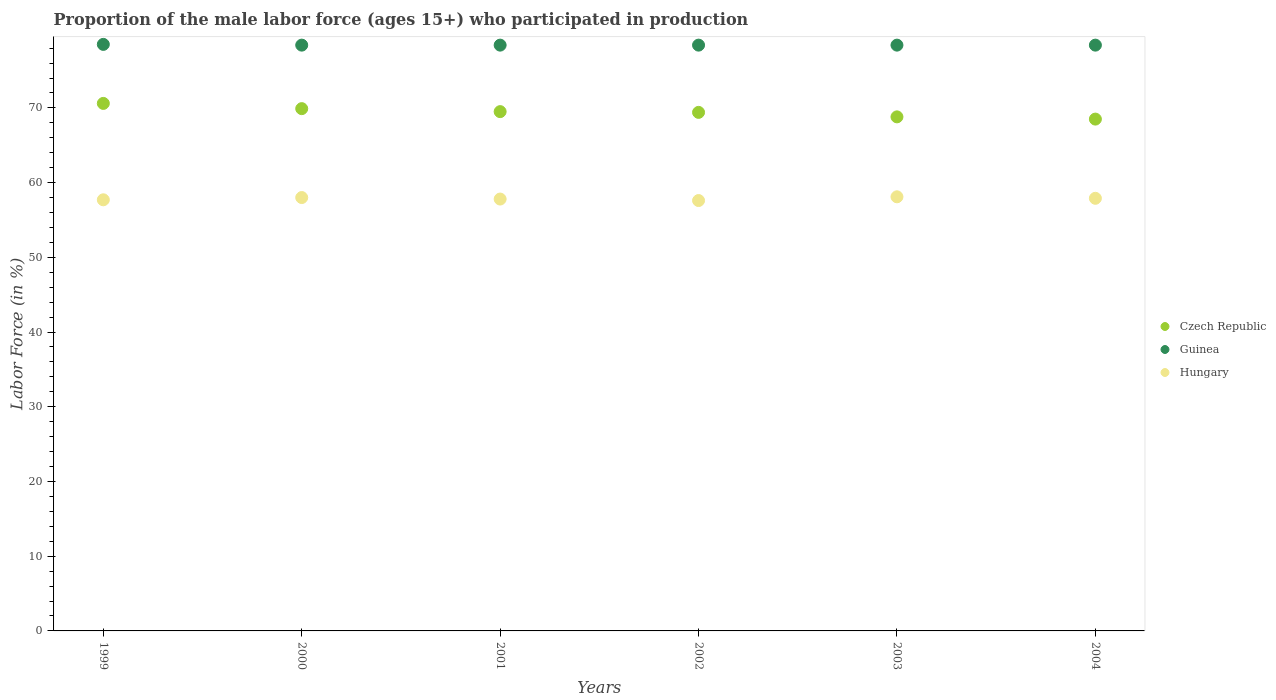How many different coloured dotlines are there?
Offer a terse response. 3. Is the number of dotlines equal to the number of legend labels?
Keep it short and to the point. Yes. What is the proportion of the male labor force who participated in production in Guinea in 2003?
Keep it short and to the point. 78.4. Across all years, what is the maximum proportion of the male labor force who participated in production in Czech Republic?
Provide a short and direct response. 70.6. Across all years, what is the minimum proportion of the male labor force who participated in production in Czech Republic?
Make the answer very short. 68.5. What is the total proportion of the male labor force who participated in production in Guinea in the graph?
Offer a terse response. 470.5. What is the difference between the proportion of the male labor force who participated in production in Guinea in 2002 and that in 2003?
Your answer should be compact. 0. What is the average proportion of the male labor force who participated in production in Czech Republic per year?
Offer a terse response. 69.45. In the year 1999, what is the difference between the proportion of the male labor force who participated in production in Hungary and proportion of the male labor force who participated in production in Guinea?
Your response must be concise. -20.8. In how many years, is the proportion of the male labor force who participated in production in Hungary greater than 60 %?
Provide a succinct answer. 0. What is the ratio of the proportion of the male labor force who participated in production in Hungary in 1999 to that in 2001?
Keep it short and to the point. 1. What is the difference between the highest and the second highest proportion of the male labor force who participated in production in Czech Republic?
Ensure brevity in your answer.  0.7. What is the difference between the highest and the lowest proportion of the male labor force who participated in production in Czech Republic?
Provide a succinct answer. 2.1. How many dotlines are there?
Your response must be concise. 3. What is the difference between two consecutive major ticks on the Y-axis?
Your response must be concise. 10. Are the values on the major ticks of Y-axis written in scientific E-notation?
Provide a short and direct response. No. Does the graph contain any zero values?
Offer a very short reply. No. Where does the legend appear in the graph?
Offer a very short reply. Center right. How many legend labels are there?
Make the answer very short. 3. How are the legend labels stacked?
Make the answer very short. Vertical. What is the title of the graph?
Your answer should be compact. Proportion of the male labor force (ages 15+) who participated in production. What is the label or title of the X-axis?
Offer a very short reply. Years. What is the Labor Force (in %) of Czech Republic in 1999?
Give a very brief answer. 70.6. What is the Labor Force (in %) of Guinea in 1999?
Give a very brief answer. 78.5. What is the Labor Force (in %) of Hungary in 1999?
Your answer should be very brief. 57.7. What is the Labor Force (in %) of Czech Republic in 2000?
Provide a short and direct response. 69.9. What is the Labor Force (in %) of Guinea in 2000?
Provide a succinct answer. 78.4. What is the Labor Force (in %) in Hungary in 2000?
Ensure brevity in your answer.  58. What is the Labor Force (in %) of Czech Republic in 2001?
Offer a very short reply. 69.5. What is the Labor Force (in %) of Guinea in 2001?
Offer a terse response. 78.4. What is the Labor Force (in %) in Hungary in 2001?
Make the answer very short. 57.8. What is the Labor Force (in %) of Czech Republic in 2002?
Your answer should be compact. 69.4. What is the Labor Force (in %) in Guinea in 2002?
Make the answer very short. 78.4. What is the Labor Force (in %) in Hungary in 2002?
Offer a terse response. 57.6. What is the Labor Force (in %) of Czech Republic in 2003?
Your answer should be very brief. 68.8. What is the Labor Force (in %) in Guinea in 2003?
Provide a succinct answer. 78.4. What is the Labor Force (in %) in Hungary in 2003?
Your answer should be compact. 58.1. What is the Labor Force (in %) of Czech Republic in 2004?
Your answer should be compact. 68.5. What is the Labor Force (in %) of Guinea in 2004?
Ensure brevity in your answer.  78.4. What is the Labor Force (in %) of Hungary in 2004?
Offer a very short reply. 57.9. Across all years, what is the maximum Labor Force (in %) in Czech Republic?
Ensure brevity in your answer.  70.6. Across all years, what is the maximum Labor Force (in %) in Guinea?
Your response must be concise. 78.5. Across all years, what is the maximum Labor Force (in %) in Hungary?
Provide a short and direct response. 58.1. Across all years, what is the minimum Labor Force (in %) in Czech Republic?
Your answer should be very brief. 68.5. Across all years, what is the minimum Labor Force (in %) of Guinea?
Give a very brief answer. 78.4. Across all years, what is the minimum Labor Force (in %) in Hungary?
Keep it short and to the point. 57.6. What is the total Labor Force (in %) in Czech Republic in the graph?
Your answer should be very brief. 416.7. What is the total Labor Force (in %) of Guinea in the graph?
Your answer should be compact. 470.5. What is the total Labor Force (in %) of Hungary in the graph?
Keep it short and to the point. 347.1. What is the difference between the Labor Force (in %) in Guinea in 1999 and that in 2000?
Provide a succinct answer. 0.1. What is the difference between the Labor Force (in %) in Czech Republic in 1999 and that in 2002?
Provide a short and direct response. 1.2. What is the difference between the Labor Force (in %) in Guinea in 1999 and that in 2002?
Your answer should be very brief. 0.1. What is the difference between the Labor Force (in %) in Hungary in 1999 and that in 2003?
Give a very brief answer. -0.4. What is the difference between the Labor Force (in %) in Guinea in 1999 and that in 2004?
Offer a terse response. 0.1. What is the difference between the Labor Force (in %) in Hungary in 2000 and that in 2001?
Offer a terse response. 0.2. What is the difference between the Labor Force (in %) of Czech Republic in 2000 and that in 2002?
Give a very brief answer. 0.5. What is the difference between the Labor Force (in %) of Hungary in 2000 and that in 2002?
Provide a succinct answer. 0.4. What is the difference between the Labor Force (in %) in Czech Republic in 2000 and that in 2003?
Provide a succinct answer. 1.1. What is the difference between the Labor Force (in %) in Guinea in 2000 and that in 2003?
Ensure brevity in your answer.  0. What is the difference between the Labor Force (in %) in Hungary in 2000 and that in 2003?
Make the answer very short. -0.1. What is the difference between the Labor Force (in %) in Czech Republic in 2000 and that in 2004?
Ensure brevity in your answer.  1.4. What is the difference between the Labor Force (in %) in Czech Republic in 2001 and that in 2002?
Your response must be concise. 0.1. What is the difference between the Labor Force (in %) of Czech Republic in 2001 and that in 2004?
Provide a short and direct response. 1. What is the difference between the Labor Force (in %) in Hungary in 2002 and that in 2003?
Provide a short and direct response. -0.5. What is the difference between the Labor Force (in %) in Hungary in 2002 and that in 2004?
Make the answer very short. -0.3. What is the difference between the Labor Force (in %) of Hungary in 2003 and that in 2004?
Ensure brevity in your answer.  0.2. What is the difference between the Labor Force (in %) in Czech Republic in 1999 and the Labor Force (in %) in Guinea in 2000?
Ensure brevity in your answer.  -7.8. What is the difference between the Labor Force (in %) in Czech Republic in 1999 and the Labor Force (in %) in Hungary in 2000?
Your response must be concise. 12.6. What is the difference between the Labor Force (in %) in Czech Republic in 1999 and the Labor Force (in %) in Guinea in 2001?
Ensure brevity in your answer.  -7.8. What is the difference between the Labor Force (in %) in Czech Republic in 1999 and the Labor Force (in %) in Hungary in 2001?
Your answer should be very brief. 12.8. What is the difference between the Labor Force (in %) in Guinea in 1999 and the Labor Force (in %) in Hungary in 2001?
Give a very brief answer. 20.7. What is the difference between the Labor Force (in %) of Czech Republic in 1999 and the Labor Force (in %) of Guinea in 2002?
Offer a very short reply. -7.8. What is the difference between the Labor Force (in %) of Guinea in 1999 and the Labor Force (in %) of Hungary in 2002?
Offer a terse response. 20.9. What is the difference between the Labor Force (in %) of Czech Republic in 1999 and the Labor Force (in %) of Hungary in 2003?
Ensure brevity in your answer.  12.5. What is the difference between the Labor Force (in %) of Guinea in 1999 and the Labor Force (in %) of Hungary in 2003?
Provide a short and direct response. 20.4. What is the difference between the Labor Force (in %) of Czech Republic in 1999 and the Labor Force (in %) of Guinea in 2004?
Offer a terse response. -7.8. What is the difference between the Labor Force (in %) in Czech Republic in 1999 and the Labor Force (in %) in Hungary in 2004?
Make the answer very short. 12.7. What is the difference between the Labor Force (in %) of Guinea in 1999 and the Labor Force (in %) of Hungary in 2004?
Provide a succinct answer. 20.6. What is the difference between the Labor Force (in %) of Guinea in 2000 and the Labor Force (in %) of Hungary in 2001?
Provide a short and direct response. 20.6. What is the difference between the Labor Force (in %) of Czech Republic in 2000 and the Labor Force (in %) of Guinea in 2002?
Your answer should be compact. -8.5. What is the difference between the Labor Force (in %) in Czech Republic in 2000 and the Labor Force (in %) in Hungary in 2002?
Your answer should be very brief. 12.3. What is the difference between the Labor Force (in %) in Guinea in 2000 and the Labor Force (in %) in Hungary in 2002?
Keep it short and to the point. 20.8. What is the difference between the Labor Force (in %) of Czech Republic in 2000 and the Labor Force (in %) of Guinea in 2003?
Your response must be concise. -8.5. What is the difference between the Labor Force (in %) of Czech Republic in 2000 and the Labor Force (in %) of Hungary in 2003?
Offer a very short reply. 11.8. What is the difference between the Labor Force (in %) in Guinea in 2000 and the Labor Force (in %) in Hungary in 2003?
Give a very brief answer. 20.3. What is the difference between the Labor Force (in %) in Czech Republic in 2000 and the Labor Force (in %) in Guinea in 2004?
Keep it short and to the point. -8.5. What is the difference between the Labor Force (in %) of Czech Republic in 2001 and the Labor Force (in %) of Hungary in 2002?
Your response must be concise. 11.9. What is the difference between the Labor Force (in %) in Guinea in 2001 and the Labor Force (in %) in Hungary in 2002?
Make the answer very short. 20.8. What is the difference between the Labor Force (in %) of Czech Republic in 2001 and the Labor Force (in %) of Guinea in 2003?
Make the answer very short. -8.9. What is the difference between the Labor Force (in %) of Czech Republic in 2001 and the Labor Force (in %) of Hungary in 2003?
Give a very brief answer. 11.4. What is the difference between the Labor Force (in %) of Guinea in 2001 and the Labor Force (in %) of Hungary in 2003?
Your answer should be very brief. 20.3. What is the difference between the Labor Force (in %) in Czech Republic in 2002 and the Labor Force (in %) in Hungary in 2003?
Your answer should be compact. 11.3. What is the difference between the Labor Force (in %) of Guinea in 2002 and the Labor Force (in %) of Hungary in 2003?
Your answer should be compact. 20.3. What is the difference between the Labor Force (in %) in Czech Republic in 2002 and the Labor Force (in %) in Hungary in 2004?
Provide a succinct answer. 11.5. What is the difference between the Labor Force (in %) of Guinea in 2002 and the Labor Force (in %) of Hungary in 2004?
Provide a short and direct response. 20.5. What is the average Labor Force (in %) in Czech Republic per year?
Ensure brevity in your answer.  69.45. What is the average Labor Force (in %) of Guinea per year?
Provide a short and direct response. 78.42. What is the average Labor Force (in %) of Hungary per year?
Give a very brief answer. 57.85. In the year 1999, what is the difference between the Labor Force (in %) of Czech Republic and Labor Force (in %) of Hungary?
Make the answer very short. 12.9. In the year 1999, what is the difference between the Labor Force (in %) in Guinea and Labor Force (in %) in Hungary?
Keep it short and to the point. 20.8. In the year 2000, what is the difference between the Labor Force (in %) of Guinea and Labor Force (in %) of Hungary?
Your response must be concise. 20.4. In the year 2001, what is the difference between the Labor Force (in %) of Czech Republic and Labor Force (in %) of Guinea?
Offer a terse response. -8.9. In the year 2001, what is the difference between the Labor Force (in %) of Guinea and Labor Force (in %) of Hungary?
Your response must be concise. 20.6. In the year 2002, what is the difference between the Labor Force (in %) in Czech Republic and Labor Force (in %) in Guinea?
Provide a short and direct response. -9. In the year 2002, what is the difference between the Labor Force (in %) in Czech Republic and Labor Force (in %) in Hungary?
Make the answer very short. 11.8. In the year 2002, what is the difference between the Labor Force (in %) of Guinea and Labor Force (in %) of Hungary?
Keep it short and to the point. 20.8. In the year 2003, what is the difference between the Labor Force (in %) in Guinea and Labor Force (in %) in Hungary?
Keep it short and to the point. 20.3. In the year 2004, what is the difference between the Labor Force (in %) of Czech Republic and Labor Force (in %) of Guinea?
Your answer should be very brief. -9.9. What is the ratio of the Labor Force (in %) of Czech Republic in 1999 to that in 2000?
Give a very brief answer. 1.01. What is the ratio of the Labor Force (in %) in Czech Republic in 1999 to that in 2001?
Offer a very short reply. 1.02. What is the ratio of the Labor Force (in %) of Guinea in 1999 to that in 2001?
Give a very brief answer. 1. What is the ratio of the Labor Force (in %) in Czech Republic in 1999 to that in 2002?
Your answer should be very brief. 1.02. What is the ratio of the Labor Force (in %) of Hungary in 1999 to that in 2002?
Keep it short and to the point. 1. What is the ratio of the Labor Force (in %) of Czech Republic in 1999 to that in 2003?
Ensure brevity in your answer.  1.03. What is the ratio of the Labor Force (in %) of Guinea in 1999 to that in 2003?
Provide a succinct answer. 1. What is the ratio of the Labor Force (in %) of Czech Republic in 1999 to that in 2004?
Offer a terse response. 1.03. What is the ratio of the Labor Force (in %) of Guinea in 1999 to that in 2004?
Make the answer very short. 1. What is the ratio of the Labor Force (in %) in Czech Republic in 2000 to that in 2001?
Make the answer very short. 1.01. What is the ratio of the Labor Force (in %) of Hungary in 2000 to that in 2001?
Ensure brevity in your answer.  1. What is the ratio of the Labor Force (in %) in Guinea in 2000 to that in 2002?
Your answer should be compact. 1. What is the ratio of the Labor Force (in %) of Guinea in 2000 to that in 2003?
Ensure brevity in your answer.  1. What is the ratio of the Labor Force (in %) of Hungary in 2000 to that in 2003?
Provide a succinct answer. 1. What is the ratio of the Labor Force (in %) in Czech Republic in 2000 to that in 2004?
Your answer should be very brief. 1.02. What is the ratio of the Labor Force (in %) of Guinea in 2000 to that in 2004?
Ensure brevity in your answer.  1. What is the ratio of the Labor Force (in %) in Hungary in 2000 to that in 2004?
Keep it short and to the point. 1. What is the ratio of the Labor Force (in %) in Hungary in 2001 to that in 2002?
Provide a short and direct response. 1. What is the ratio of the Labor Force (in %) of Czech Republic in 2001 to that in 2003?
Your answer should be very brief. 1.01. What is the ratio of the Labor Force (in %) in Guinea in 2001 to that in 2003?
Keep it short and to the point. 1. What is the ratio of the Labor Force (in %) of Czech Republic in 2001 to that in 2004?
Keep it short and to the point. 1.01. What is the ratio of the Labor Force (in %) of Hungary in 2001 to that in 2004?
Give a very brief answer. 1. What is the ratio of the Labor Force (in %) in Czech Republic in 2002 to that in 2003?
Ensure brevity in your answer.  1.01. What is the ratio of the Labor Force (in %) in Guinea in 2002 to that in 2003?
Your answer should be very brief. 1. What is the ratio of the Labor Force (in %) in Hungary in 2002 to that in 2003?
Your answer should be very brief. 0.99. What is the ratio of the Labor Force (in %) in Czech Republic in 2002 to that in 2004?
Ensure brevity in your answer.  1.01. What is the ratio of the Labor Force (in %) in Guinea in 2002 to that in 2004?
Offer a very short reply. 1. What is the ratio of the Labor Force (in %) of Czech Republic in 2003 to that in 2004?
Keep it short and to the point. 1. What is the ratio of the Labor Force (in %) in Guinea in 2003 to that in 2004?
Provide a succinct answer. 1. What is the difference between the highest and the second highest Labor Force (in %) in Hungary?
Ensure brevity in your answer.  0.1. What is the difference between the highest and the lowest Labor Force (in %) in Guinea?
Your answer should be compact. 0.1. What is the difference between the highest and the lowest Labor Force (in %) of Hungary?
Offer a terse response. 0.5. 